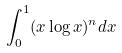Convert formula to latex. <formula><loc_0><loc_0><loc_500><loc_500>\int _ { 0 } ^ { 1 } ( x \log x ) ^ { n } d x</formula> 